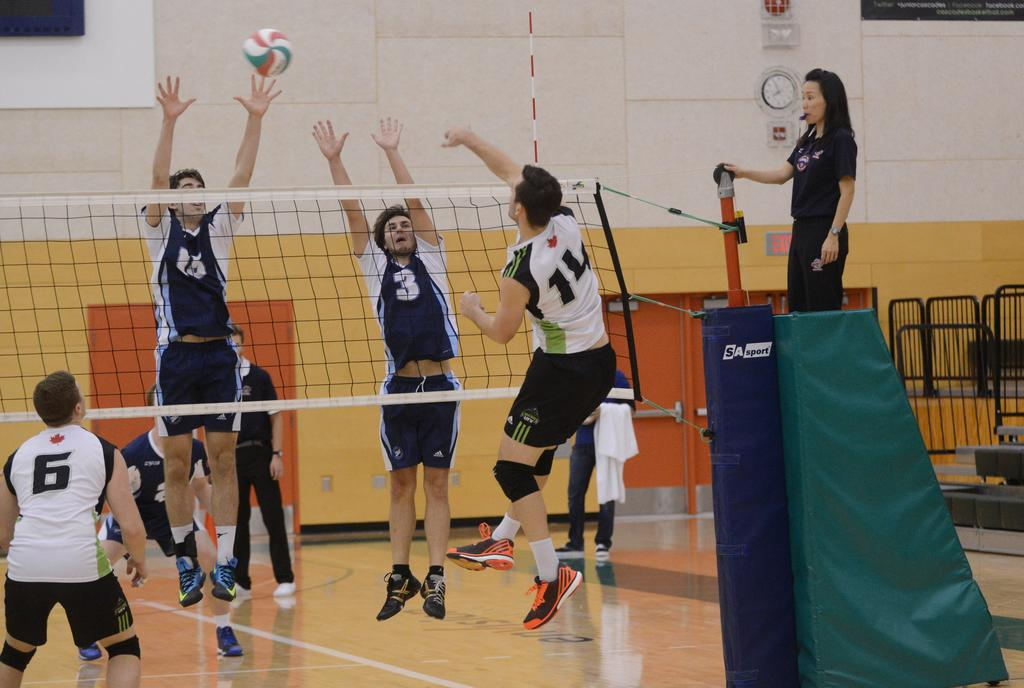<image>
Present a compact description of the photo's key features. Volleyball player wearing number 14 is spiking the ball. 